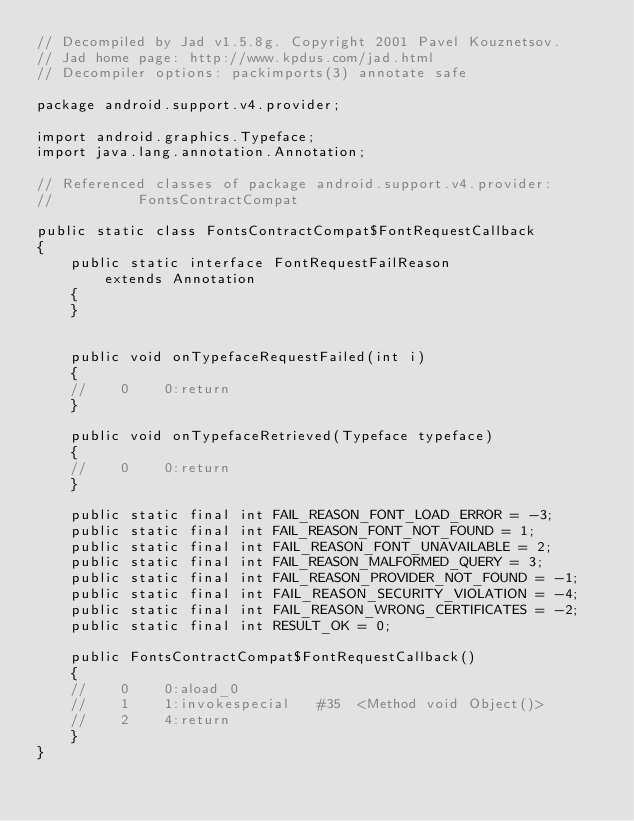<code> <loc_0><loc_0><loc_500><loc_500><_Java_>// Decompiled by Jad v1.5.8g. Copyright 2001 Pavel Kouznetsov.
// Jad home page: http://www.kpdus.com/jad.html
// Decompiler options: packimports(3) annotate safe 

package android.support.v4.provider;

import android.graphics.Typeface;
import java.lang.annotation.Annotation;

// Referenced classes of package android.support.v4.provider:
//			FontsContractCompat

public static class FontsContractCompat$FontRequestCallback
{
	public static interface FontRequestFailReason
		extends Annotation
	{
	}


	public void onTypefaceRequestFailed(int i)
	{
	//    0    0:return          
	}

	public void onTypefaceRetrieved(Typeface typeface)
	{
	//    0    0:return          
	}

	public static final int FAIL_REASON_FONT_LOAD_ERROR = -3;
	public static final int FAIL_REASON_FONT_NOT_FOUND = 1;
	public static final int FAIL_REASON_FONT_UNAVAILABLE = 2;
	public static final int FAIL_REASON_MALFORMED_QUERY = 3;
	public static final int FAIL_REASON_PROVIDER_NOT_FOUND = -1;
	public static final int FAIL_REASON_SECURITY_VIOLATION = -4;
	public static final int FAIL_REASON_WRONG_CERTIFICATES = -2;
	public static final int RESULT_OK = 0;

	public FontsContractCompat$FontRequestCallback()
	{
	//    0    0:aload_0         
	//    1    1:invokespecial   #35  <Method void Object()>
	//    2    4:return          
	}
}
</code> 